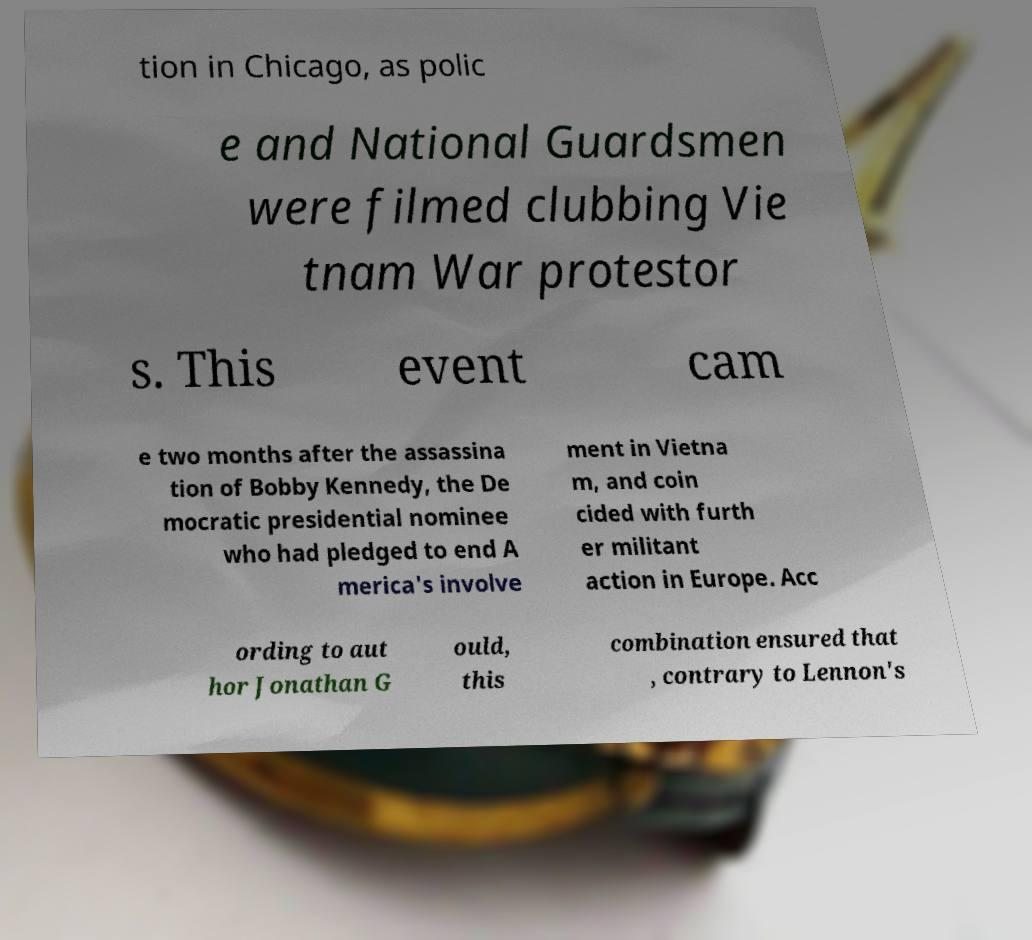I need the written content from this picture converted into text. Can you do that? tion in Chicago, as polic e and National Guardsmen were filmed clubbing Vie tnam War protestor s. This event cam e two months after the assassina tion of Bobby Kennedy, the De mocratic presidential nominee who had pledged to end A merica's involve ment in Vietna m, and coin cided with furth er militant action in Europe. Acc ording to aut hor Jonathan G ould, this combination ensured that , contrary to Lennon's 